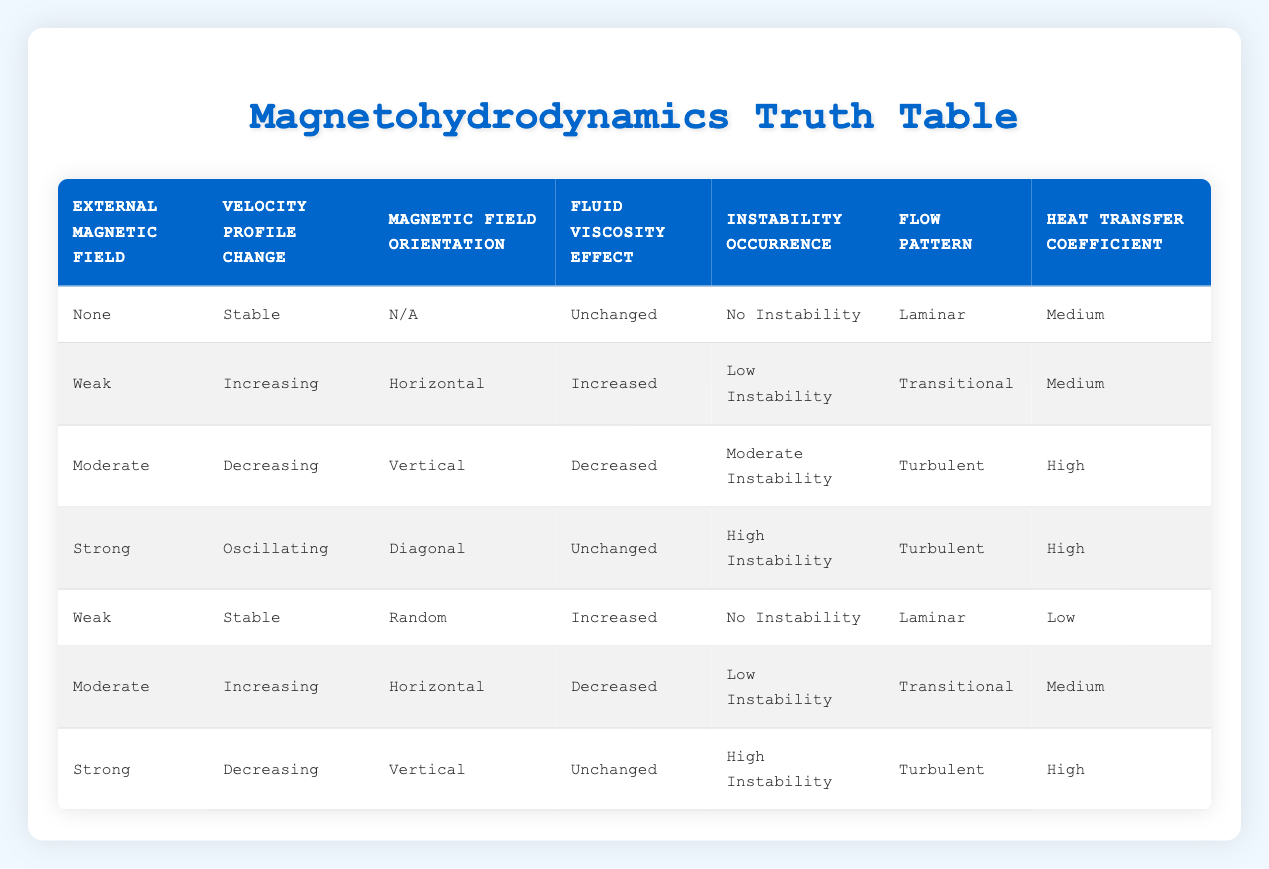What is the Heat Transfer Coefficient when there is a Strong External Magnetic Field? According to the table, when the External Magnetic Field is Strong, the Heat Transfer Coefficient is High.
Answer: High How many data points show a Stable Velocity Profile Change? There are three instances in the table that indicate a Stable Velocity Profile Change: when the External Magnetic Field is None, Weak (Random orientation), and Moderate (Horizontal orientation).
Answer: 3 Is it true that a Weak External Magnetic Field always leads to increased Fluid Viscosity Effect? In the table, there are two instances of Weak External Magnetic Field: one with an Increased Fluid Viscosity Effect and another with Unchanged Fluid Viscosity Effect. Hence, it is false that it always leads to an increase.
Answer: False What is the Flow Pattern when the Instability Occurrence is Low? In the table, there are two instances with Low Instability Occurrence: one corresponds to a Transitional Flow Pattern (Weak, Horizontal orientation) and the other to a Transitional Flow Pattern (Moderate, Horizontal orientation). Therefore, the Flow Pattern when Instability Occurrence is Low could be Transitional.
Answer: Transitional Calculate the difference in Heat Transfer Coefficient between the Strong external magnetic field with Decreasing Velocity Profile Change and Weak external magnetic field showing a Stable Velocity Profile Change. The Heat Transfer Coefficient with Strong Field (Decreasing profile) is High, while for the Weak Field (Stable profile), it is Low. The difference is High - Low, which is High (considering High being more than Low).
Answer: High What type of Flow Pattern is observed when there is a Moderate External Magnetic Field and the Instability Occurrence is Moderate? The table indicates that with a Moderate External Magnetic Field and Moderate Instability Occurrence, the Flow Pattern is Turbulent.
Answer: Turbulent Do any of the data points show a Horizontal Magnetic Field Orientation with No Instability? By examining the table, the data point with a Horizontal Magnetic Field Orientation (Weak) does indeed present a Low Instability Occurrence; thus, there are no points showing No Instability under Horizontal orientation.
Answer: No Which External Magnetic Field leads to an Oscillating Velocity Profile Change? Referring to the table, only the Strong External Magnetic Field leads to an Oscillating Velocity Profile Change.
Answer: Strong 